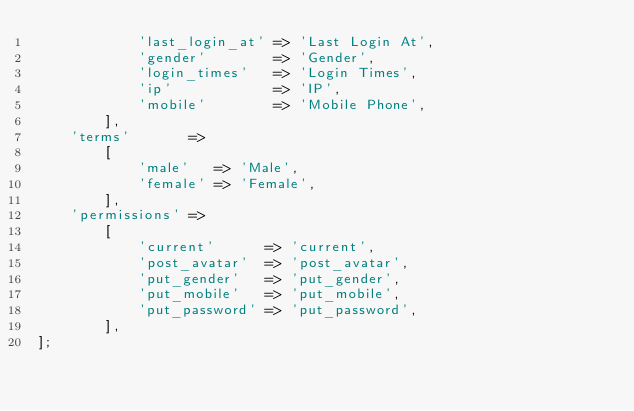<code> <loc_0><loc_0><loc_500><loc_500><_PHP_>            'last_login_at' => 'Last Login At',
            'gender'        => 'Gender',
            'login_times'   => 'Login Times',
            'ip'            => 'IP',
            'mobile'        => 'Mobile Phone',
        ],
    'terms'       =>
        [
            'male'   => 'Male',
            'female' => 'Female',
        ],
    'permissions' =>
        [
            'current'      => 'current',
            'post_avatar'  => 'post_avatar',
            'put_gender'   => 'put_gender',
            'put_mobile'   => 'put_mobile',
            'put_password' => 'put_password',
        ],
];
</code> 